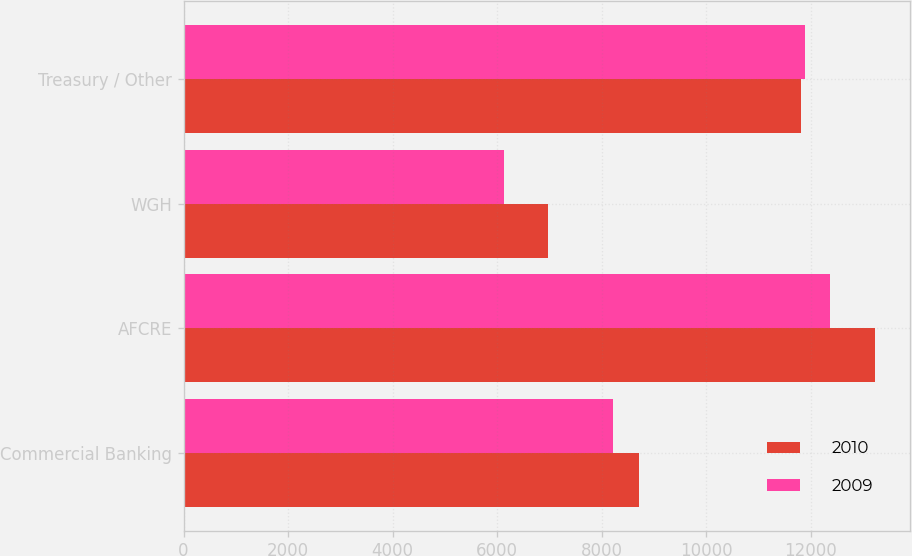<chart> <loc_0><loc_0><loc_500><loc_500><stacked_bar_chart><ecel><fcel>Commercial Banking<fcel>AFCRE<fcel>WGH<fcel>Treasury / Other<nl><fcel>2010<fcel>8720<fcel>13233<fcel>6971<fcel>11808<nl><fcel>2009<fcel>8214<fcel>12361<fcel>6125<fcel>11883<nl></chart> 